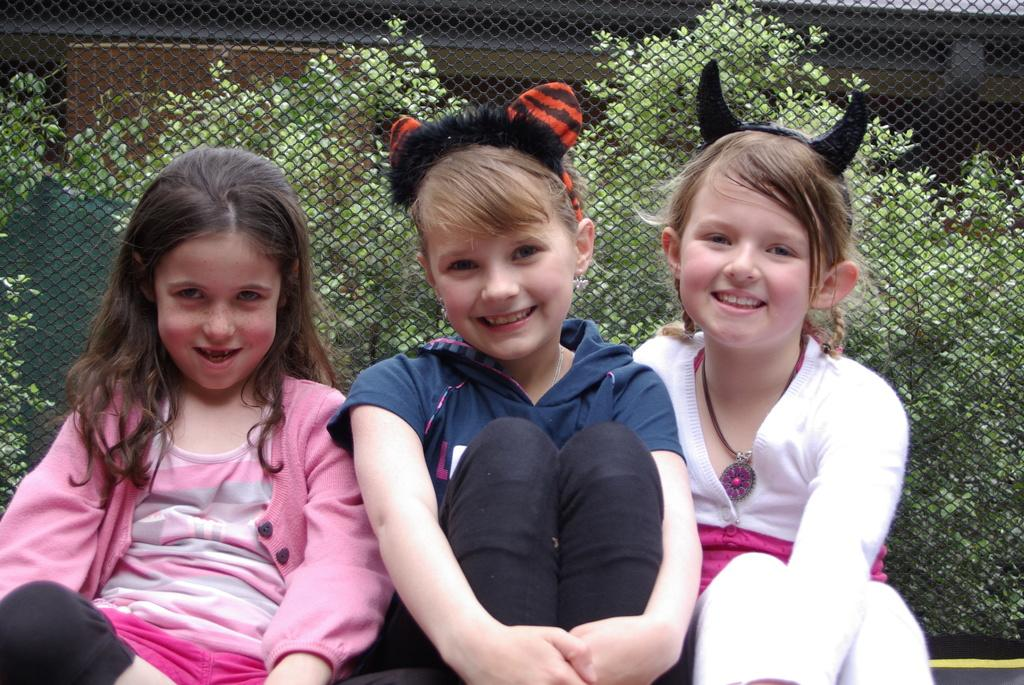How many girls are in the image? There are three girls in the image. What are the girls wearing? The girls are wearing different color dresses. What is the facial expression of the girls? The girls are smiling. What are the girls doing in the image? The girls are sitting. What is located beside the girls? There is a fence beside the girls. What can be seen in the background of the image? There are plants in the background of the image. How would you describe the color of the background? The background of the image is dark in color. What type of degree is the girl on the left holding in the image? There is no degree visible in the image, and the girls are not holding anything. What instrument is the girl on the right playing in the image? There is no instrument present in the image; the girls are simply sitting and smiling. 